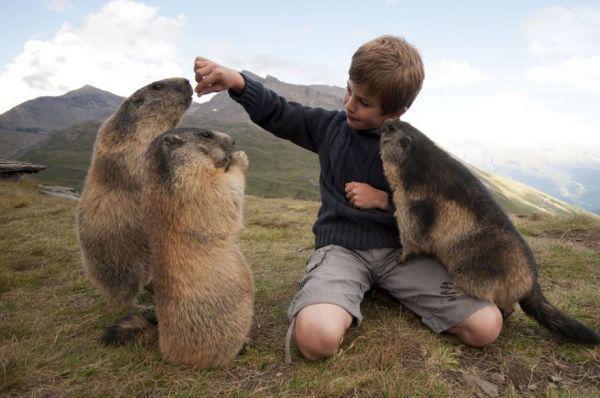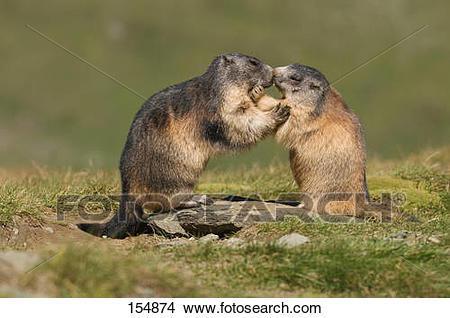The first image is the image on the left, the second image is the image on the right. Examine the images to the left and right. Is the description "A young boy is next to at least one groundhog." accurate? Answer yes or no. Yes. The first image is the image on the left, the second image is the image on the right. Assess this claim about the two images: "In one image there is a boy next to at least one marmot.". Correct or not? Answer yes or no. Yes. 